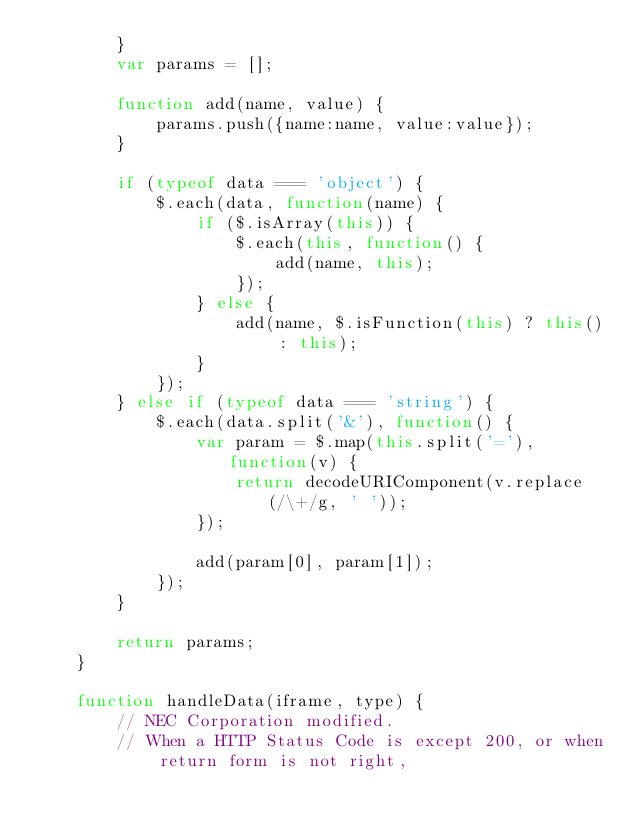Convert code to text. <code><loc_0><loc_0><loc_500><loc_500><_JavaScript_>		}
		var params = [];

		function add(name, value) {
			params.push({name:name, value:value});
		}

		if (typeof data === 'object') {
			$.each(data, function(name) {
				if ($.isArray(this)) {
					$.each(this, function() {
						add(name, this);
					});
				} else {
					add(name, $.isFunction(this) ? this() : this);
				}
			});
		} else if (typeof data === 'string') {
			$.each(data.split('&'), function() {
				var param = $.map(this.split('='), function(v) {
					return decodeURIComponent(v.replace(/\+/g, ' '));
				});

				add(param[0], param[1]);
			});
		}

		return params;
	}

	function handleData(iframe, type) {
		// NEC Corporation modified.
		// When a HTTP Status Code is except 200, or when return form is not right,</code> 